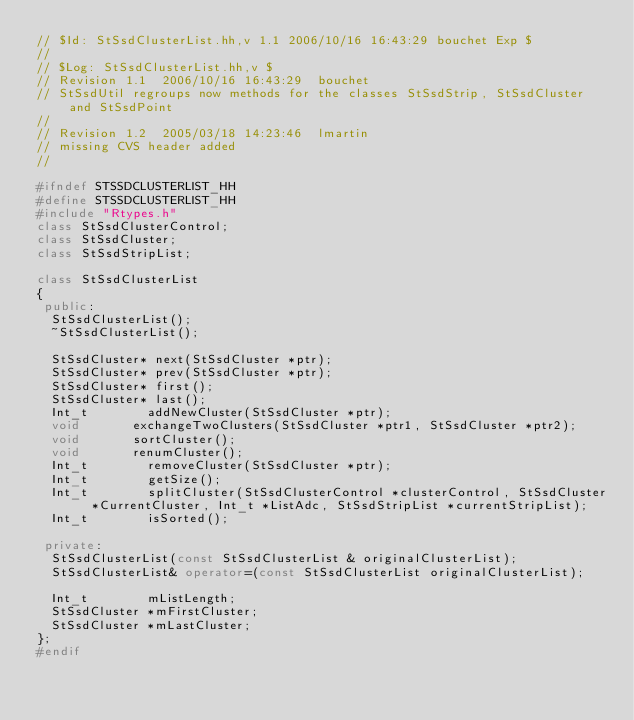Convert code to text. <code><loc_0><loc_0><loc_500><loc_500><_C++_>// $Id: StSsdClusterList.hh,v 1.1 2006/10/16 16:43:29 bouchet Exp $
//
// $Log: StSsdClusterList.hh,v $
// Revision 1.1  2006/10/16 16:43:29  bouchet
// StSsdUtil regroups now methods for the classes StSsdStrip, StSsdCluster and StSsdPoint
//
// Revision 1.2  2005/03/18 14:23:46  lmartin
// missing CVS header added
//

#ifndef STSSDCLUSTERLIST_HH
#define STSSDCLUSTERLIST_HH
#include "Rtypes.h"
class StSsdClusterControl;
class StSsdCluster;
class StSsdStripList;

class StSsdClusterList
{
 public:
  StSsdClusterList();
  ~StSsdClusterList();

  StSsdCluster* next(StSsdCluster *ptr);
  StSsdCluster* prev(StSsdCluster *ptr);
  StSsdCluster* first();
  StSsdCluster* last();  
  Int_t        addNewCluster(StSsdCluster *ptr);
  void       exchangeTwoClusters(StSsdCluster *ptr1, StSsdCluster *ptr2);
  void       sortCluster();
  void       renumCluster();
  Int_t        removeCluster(StSsdCluster *ptr);
  Int_t        getSize();
  Int_t        splitCluster(StSsdClusterControl *clusterControl, StSsdCluster *CurrentCluster, Int_t *ListAdc, StSsdStripList *currentStripList);
  Int_t        isSorted();

 private:
  StSsdClusterList(const StSsdClusterList & originalClusterList);
  StSsdClusterList& operator=(const StSsdClusterList originalClusterList);

  Int_t        mListLength;
  StSsdCluster *mFirstCluster;
  StSsdCluster *mLastCluster;
};
#endif
</code> 